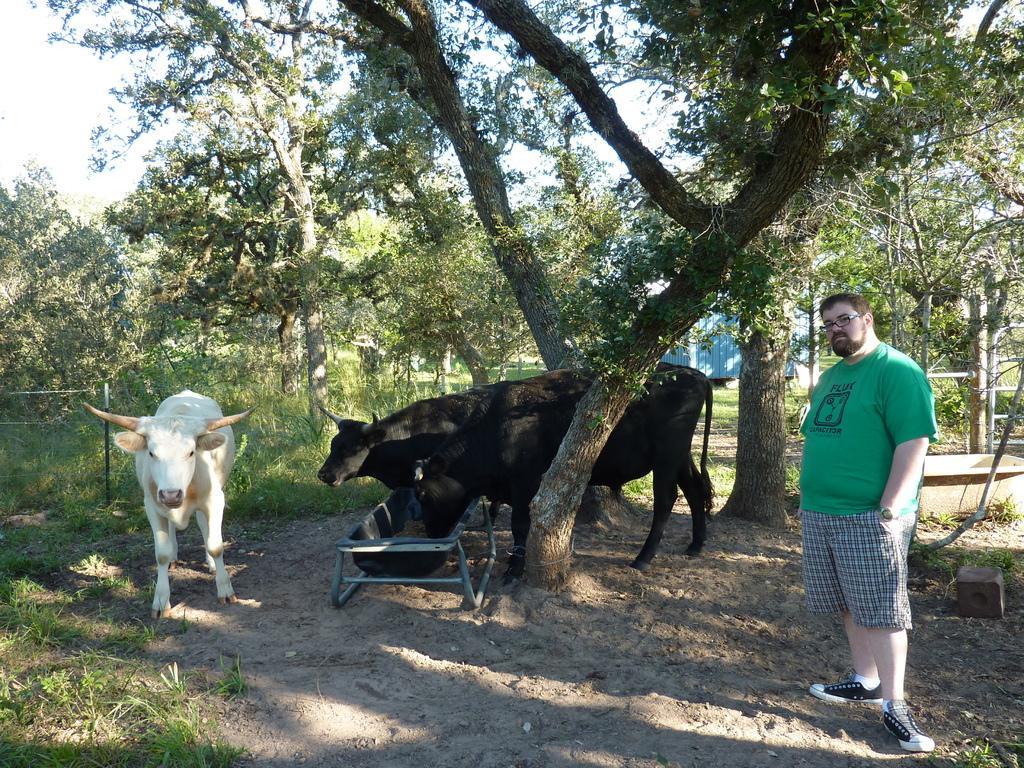How would you summarize this image in a sentence or two? Here we can see three animals. One animal is eating food. Right side of the image a person is standing. Background there are trees and grass. 